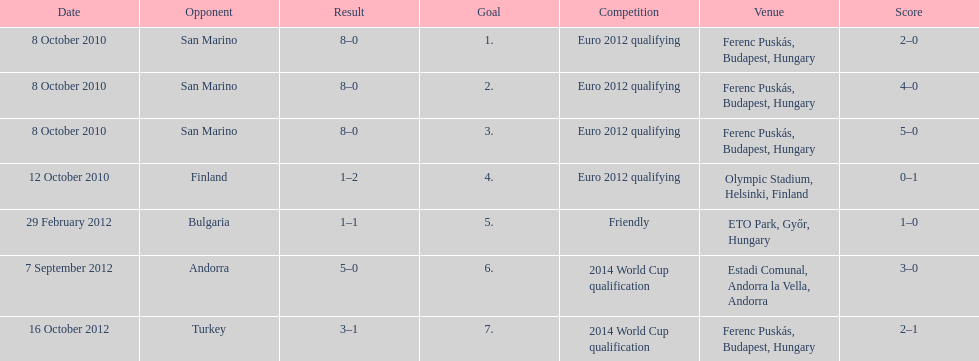How many non-qualifying games did he score in? 1. 